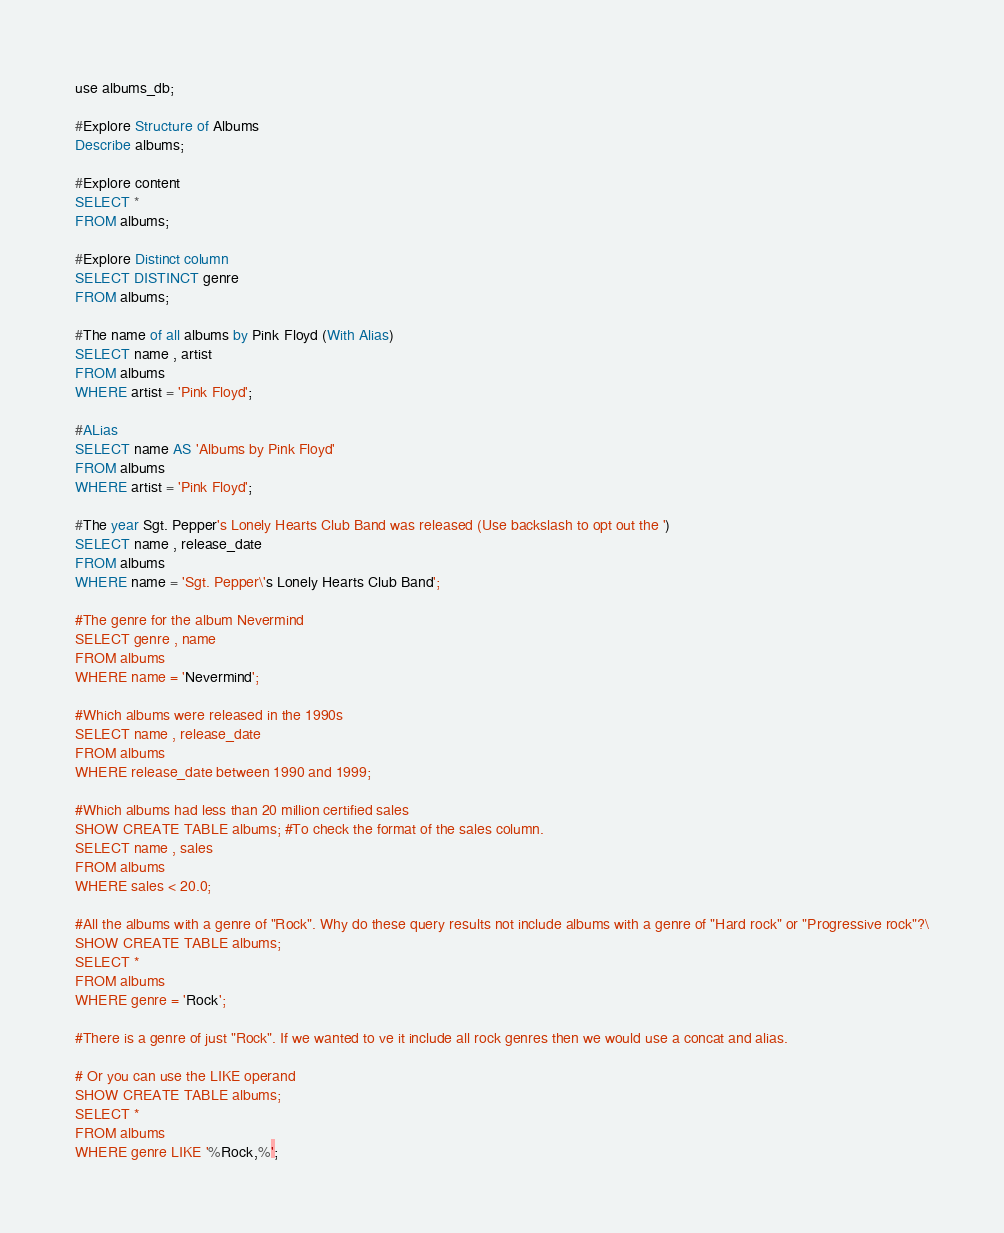Convert code to text. <code><loc_0><loc_0><loc_500><loc_500><_SQL_>use albums_db;

#Explore Structure of Albums
Describe albums;

#Explore content
SELECT *
FROM albums;

#Explore Distinct column
SELECT DISTINCT genre
FROM albums;

#The name of all albums by Pink Floyd (With Alias)
SELECT name , artist
FROM albums
WHERE artist = 'Pink Floyd';

#ALias
SELECT name AS 'Albums by Pink Floyd'
FROM albums
WHERE artist = 'Pink Floyd';

#The year Sgt. Pepper's Lonely Hearts Club Band was released (Use backslash to opt out the ')
SELECT name , release_date
FROM albums
WHERE name = 'Sgt. Pepper\'s Lonely Hearts Club Band';

#The genre for the album Nevermind
SELECT genre , name 
FROM albums
WHERE name = 'Nevermind';

#Which albums were released in the 1990s
SELECT name , release_date
FROM albums
WHERE release_date between 1990 and 1999;

#Which albums had less than 20 million certified sales
SHOW CREATE TABLE albums; #To check the format of the sales column.
SELECT name , sales
FROM albums
WHERE sales < 20.0;

#All the albums with a genre of "Rock". Why do these query results not include albums with a genre of "Hard rock" or "Progressive rock"?\
SHOW CREATE TABLE albums;
SELECT *
FROM albums
WHERE genre = 'Rock'; 

#There is a genre of just "Rock". If we wanted to ve it include all rock genres then we would use a concat and alias. 

# Or you can use the LIKE operand
SHOW CREATE TABLE albums;
SELECT *
FROM albums
WHERE genre LIKE '%Rock,%';</code> 